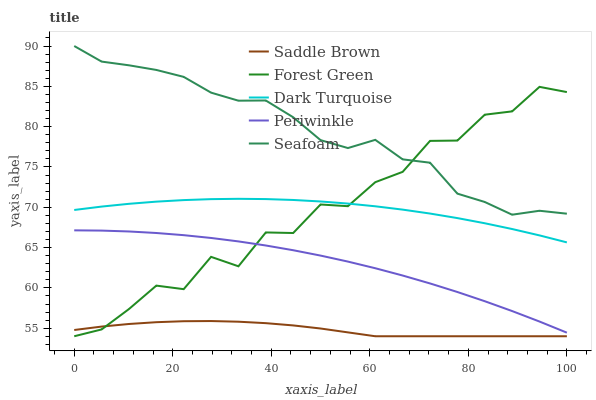Does Saddle Brown have the minimum area under the curve?
Answer yes or no. Yes. Does Seafoam have the maximum area under the curve?
Answer yes or no. Yes. Does Forest Green have the minimum area under the curve?
Answer yes or no. No. Does Forest Green have the maximum area under the curve?
Answer yes or no. No. Is Dark Turquoise the smoothest?
Answer yes or no. Yes. Is Forest Green the roughest?
Answer yes or no. Yes. Is Periwinkle the smoothest?
Answer yes or no. No. Is Periwinkle the roughest?
Answer yes or no. No. Does Forest Green have the lowest value?
Answer yes or no. Yes. Does Periwinkle have the lowest value?
Answer yes or no. No. Does Seafoam have the highest value?
Answer yes or no. Yes. Does Forest Green have the highest value?
Answer yes or no. No. Is Periwinkle less than Seafoam?
Answer yes or no. Yes. Is Seafoam greater than Dark Turquoise?
Answer yes or no. Yes. Does Forest Green intersect Seafoam?
Answer yes or no. Yes. Is Forest Green less than Seafoam?
Answer yes or no. No. Is Forest Green greater than Seafoam?
Answer yes or no. No. Does Periwinkle intersect Seafoam?
Answer yes or no. No. 